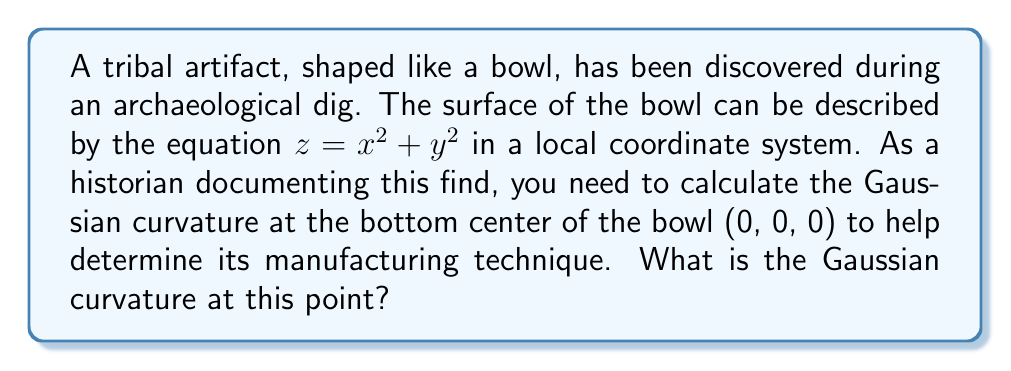What is the answer to this math problem? To calculate the Gaussian curvature, we'll follow these steps:

1) The Gaussian curvature K is given by $K = \frac{LN - M^2}{EG - F^2}$, where E, F, G are the coefficients of the first fundamental form, and L, M, N are the coefficients of the second fundamental form.

2) For a surface $z = f(x,y)$, we have:
   $E = 1 + (\frac{\partial f}{\partial x})^2$
   $F = \frac{\partial f}{\partial x}\frac{\partial f}{\partial y}$
   $G = 1 + (\frac{\partial f}{\partial y})^2$
   $L = \frac{\frac{\partial^2 f}{\partial x^2}}{\sqrt{1+(\frac{\partial f}{\partial x})^2+(\frac{\partial f}{\partial y})^2}}$
   $M = \frac{\frac{\partial^2 f}{\partial x\partial y}}{\sqrt{1+(\frac{\partial f}{\partial x})^2+(\frac{\partial f}{\partial y})^2}}$
   $N = \frac{\frac{\partial^2 f}{\partial y^2}}{\sqrt{1+(\frac{\partial f}{\partial x})^2+(\frac{\partial f}{\partial y})^2}}$

3) For our surface $z = x^2 + y^2$:
   $\frac{\partial f}{\partial x} = 2x$, $\frac{\partial f}{\partial y} = 2y$
   $\frac{\partial^2 f}{\partial x^2} = 2$, $\frac{\partial^2 f}{\partial y^2} = 2$, $\frac{\partial^2 f}{\partial x\partial y} = 0$

4) At the point (0, 0, 0):
   $E = 1 + (2x)^2 = 1$
   $F = (2x)(2y) = 0$
   $G = 1 + (2y)^2 = 1$
   $L = \frac{2}{\sqrt{1+(2x)^2+(2y)^2}} = 2$
   $M = 0$
   $N = \frac{2}{\sqrt{1+(2x)^2+(2y)^2}} = 2$

5) Substituting into the Gaussian curvature formula:
   $K = \frac{LN - M^2}{EG - F^2} = \frac{(2)(2) - 0^2}{(1)(1) - 0^2} = 4$

Therefore, the Gaussian curvature at the bottom center of the bowl is 4.
Answer: 4 